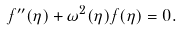Convert formula to latex. <formula><loc_0><loc_0><loc_500><loc_500>f ^ { \prime \prime } ( \eta ) + \omega ^ { 2 } ( \eta ) f ( \eta ) = 0 .</formula> 